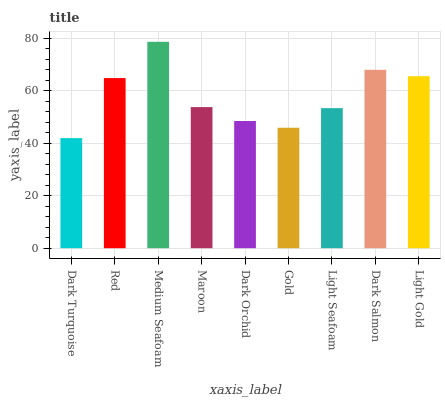Is Dark Turquoise the minimum?
Answer yes or no. Yes. Is Medium Seafoam the maximum?
Answer yes or no. Yes. Is Red the minimum?
Answer yes or no. No. Is Red the maximum?
Answer yes or no. No. Is Red greater than Dark Turquoise?
Answer yes or no. Yes. Is Dark Turquoise less than Red?
Answer yes or no. Yes. Is Dark Turquoise greater than Red?
Answer yes or no. No. Is Red less than Dark Turquoise?
Answer yes or no. No. Is Maroon the high median?
Answer yes or no. Yes. Is Maroon the low median?
Answer yes or no. Yes. Is Light Gold the high median?
Answer yes or no. No. Is Light Seafoam the low median?
Answer yes or no. No. 